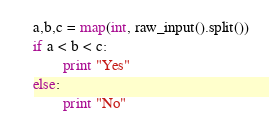<code> <loc_0><loc_0><loc_500><loc_500><_Python_>a,b,c = map(int, raw_input().split())
if a < b < c:
        print "Yes"
else:
        print "No"</code> 